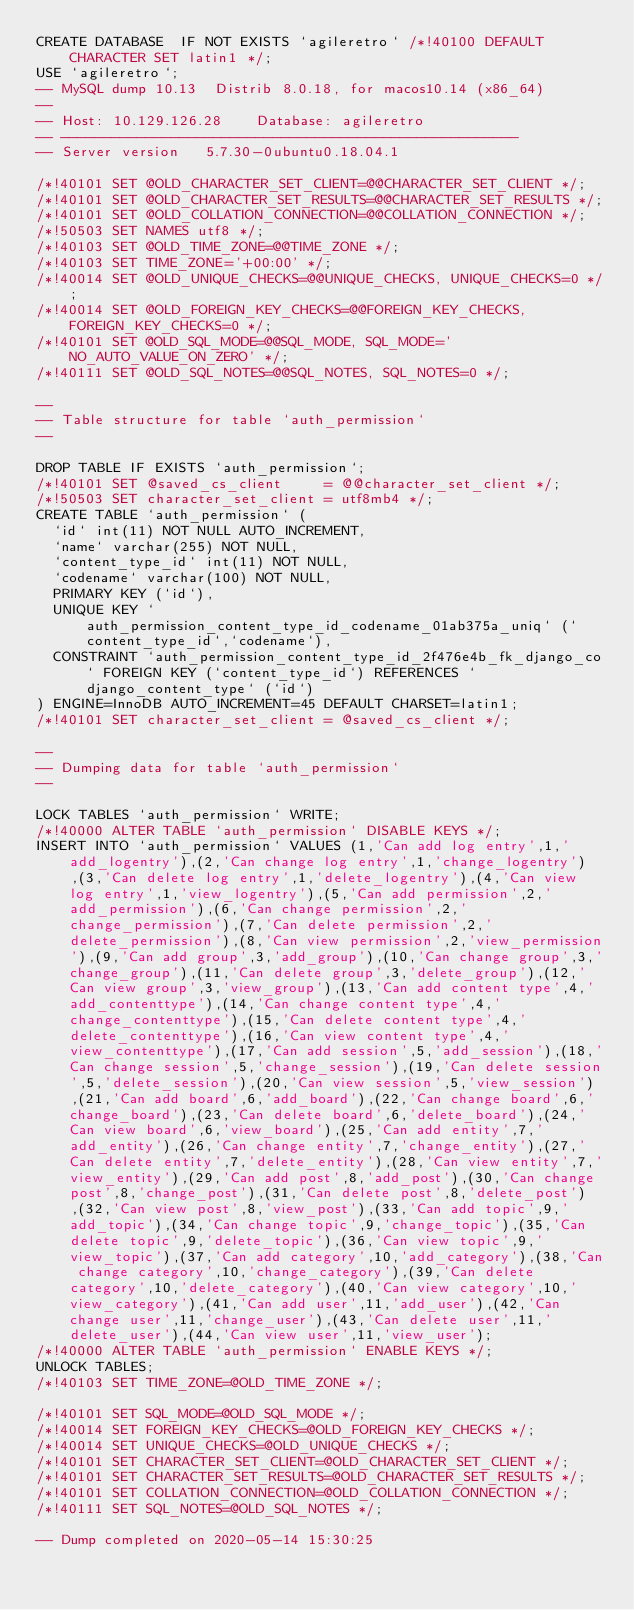Convert code to text. <code><loc_0><loc_0><loc_500><loc_500><_SQL_>CREATE DATABASE  IF NOT EXISTS `agileretro` /*!40100 DEFAULT CHARACTER SET latin1 */;
USE `agileretro`;
-- MySQL dump 10.13  Distrib 8.0.18, for macos10.14 (x86_64)
--
-- Host: 10.129.126.28    Database: agileretro
-- ------------------------------------------------------
-- Server version	5.7.30-0ubuntu0.18.04.1

/*!40101 SET @OLD_CHARACTER_SET_CLIENT=@@CHARACTER_SET_CLIENT */;
/*!40101 SET @OLD_CHARACTER_SET_RESULTS=@@CHARACTER_SET_RESULTS */;
/*!40101 SET @OLD_COLLATION_CONNECTION=@@COLLATION_CONNECTION */;
/*!50503 SET NAMES utf8 */;
/*!40103 SET @OLD_TIME_ZONE=@@TIME_ZONE */;
/*!40103 SET TIME_ZONE='+00:00' */;
/*!40014 SET @OLD_UNIQUE_CHECKS=@@UNIQUE_CHECKS, UNIQUE_CHECKS=0 */;
/*!40014 SET @OLD_FOREIGN_KEY_CHECKS=@@FOREIGN_KEY_CHECKS, FOREIGN_KEY_CHECKS=0 */;
/*!40101 SET @OLD_SQL_MODE=@@SQL_MODE, SQL_MODE='NO_AUTO_VALUE_ON_ZERO' */;
/*!40111 SET @OLD_SQL_NOTES=@@SQL_NOTES, SQL_NOTES=0 */;

--
-- Table structure for table `auth_permission`
--

DROP TABLE IF EXISTS `auth_permission`;
/*!40101 SET @saved_cs_client     = @@character_set_client */;
/*!50503 SET character_set_client = utf8mb4 */;
CREATE TABLE `auth_permission` (
  `id` int(11) NOT NULL AUTO_INCREMENT,
  `name` varchar(255) NOT NULL,
  `content_type_id` int(11) NOT NULL,
  `codename` varchar(100) NOT NULL,
  PRIMARY KEY (`id`),
  UNIQUE KEY `auth_permission_content_type_id_codename_01ab375a_uniq` (`content_type_id`,`codename`),
  CONSTRAINT `auth_permission_content_type_id_2f476e4b_fk_django_co` FOREIGN KEY (`content_type_id`) REFERENCES `django_content_type` (`id`)
) ENGINE=InnoDB AUTO_INCREMENT=45 DEFAULT CHARSET=latin1;
/*!40101 SET character_set_client = @saved_cs_client */;

--
-- Dumping data for table `auth_permission`
--

LOCK TABLES `auth_permission` WRITE;
/*!40000 ALTER TABLE `auth_permission` DISABLE KEYS */;
INSERT INTO `auth_permission` VALUES (1,'Can add log entry',1,'add_logentry'),(2,'Can change log entry',1,'change_logentry'),(3,'Can delete log entry',1,'delete_logentry'),(4,'Can view log entry',1,'view_logentry'),(5,'Can add permission',2,'add_permission'),(6,'Can change permission',2,'change_permission'),(7,'Can delete permission',2,'delete_permission'),(8,'Can view permission',2,'view_permission'),(9,'Can add group',3,'add_group'),(10,'Can change group',3,'change_group'),(11,'Can delete group',3,'delete_group'),(12,'Can view group',3,'view_group'),(13,'Can add content type',4,'add_contenttype'),(14,'Can change content type',4,'change_contenttype'),(15,'Can delete content type',4,'delete_contenttype'),(16,'Can view content type',4,'view_contenttype'),(17,'Can add session',5,'add_session'),(18,'Can change session',5,'change_session'),(19,'Can delete session',5,'delete_session'),(20,'Can view session',5,'view_session'),(21,'Can add board',6,'add_board'),(22,'Can change board',6,'change_board'),(23,'Can delete board',6,'delete_board'),(24,'Can view board',6,'view_board'),(25,'Can add entity',7,'add_entity'),(26,'Can change entity',7,'change_entity'),(27,'Can delete entity',7,'delete_entity'),(28,'Can view entity',7,'view_entity'),(29,'Can add post',8,'add_post'),(30,'Can change post',8,'change_post'),(31,'Can delete post',8,'delete_post'),(32,'Can view post',8,'view_post'),(33,'Can add topic',9,'add_topic'),(34,'Can change topic',9,'change_topic'),(35,'Can delete topic',9,'delete_topic'),(36,'Can view topic',9,'view_topic'),(37,'Can add category',10,'add_category'),(38,'Can change category',10,'change_category'),(39,'Can delete category',10,'delete_category'),(40,'Can view category',10,'view_category'),(41,'Can add user',11,'add_user'),(42,'Can change user',11,'change_user'),(43,'Can delete user',11,'delete_user'),(44,'Can view user',11,'view_user');
/*!40000 ALTER TABLE `auth_permission` ENABLE KEYS */;
UNLOCK TABLES;
/*!40103 SET TIME_ZONE=@OLD_TIME_ZONE */;

/*!40101 SET SQL_MODE=@OLD_SQL_MODE */;
/*!40014 SET FOREIGN_KEY_CHECKS=@OLD_FOREIGN_KEY_CHECKS */;
/*!40014 SET UNIQUE_CHECKS=@OLD_UNIQUE_CHECKS */;
/*!40101 SET CHARACTER_SET_CLIENT=@OLD_CHARACTER_SET_CLIENT */;
/*!40101 SET CHARACTER_SET_RESULTS=@OLD_CHARACTER_SET_RESULTS */;
/*!40101 SET COLLATION_CONNECTION=@OLD_COLLATION_CONNECTION */;
/*!40111 SET SQL_NOTES=@OLD_SQL_NOTES */;

-- Dump completed on 2020-05-14 15:30:25
</code> 